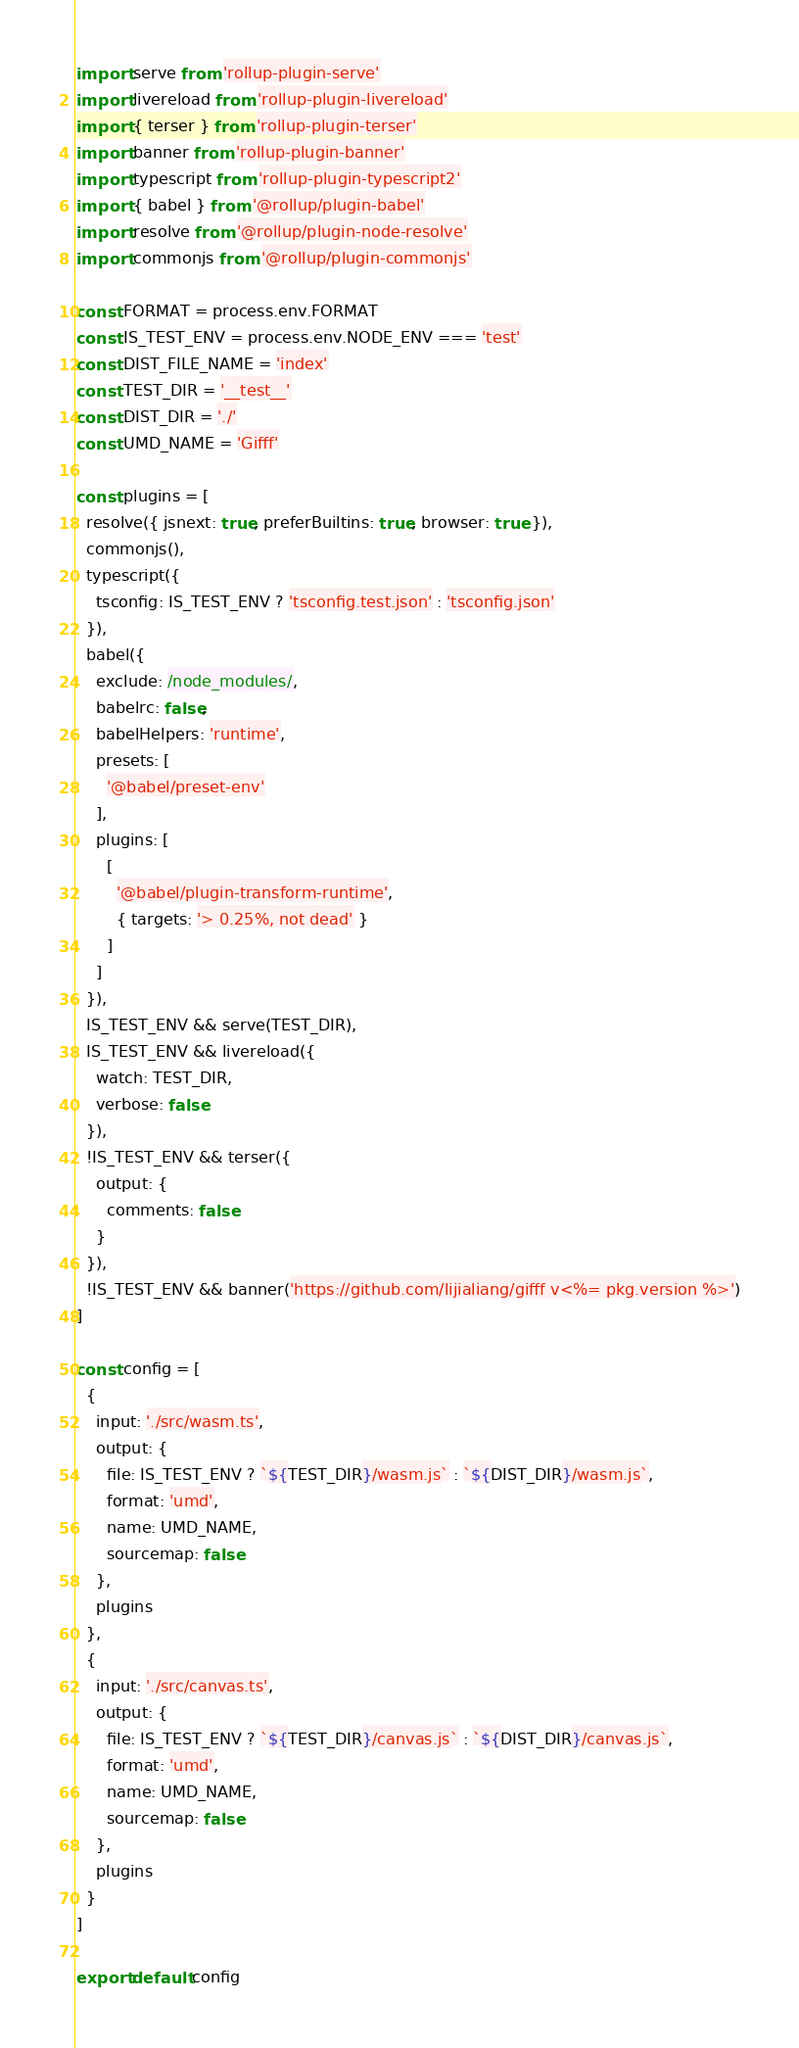<code> <loc_0><loc_0><loc_500><loc_500><_JavaScript_>import serve from 'rollup-plugin-serve'
import livereload from 'rollup-plugin-livereload'
import { terser } from 'rollup-plugin-terser'
import banner from 'rollup-plugin-banner'
import typescript from 'rollup-plugin-typescript2'
import { babel } from '@rollup/plugin-babel'
import resolve from '@rollup/plugin-node-resolve'
import commonjs from '@rollup/plugin-commonjs'

const FORMAT = process.env.FORMAT
const IS_TEST_ENV = process.env.NODE_ENV === 'test'
const DIST_FILE_NAME = 'index'
const TEST_DIR = '__test__'
const DIST_DIR = './'
const UMD_NAME = 'Gifff'

const plugins = [
  resolve({ jsnext: true, preferBuiltins: true, browser: true }),
  commonjs(),
  typescript({
    tsconfig: IS_TEST_ENV ? 'tsconfig.test.json' : 'tsconfig.json'
  }),
  babel({
    exclude: /node_modules/,
    babelrc: false,
    babelHelpers: 'runtime',
    presets: [
      '@babel/preset-env'
    ],
    plugins: [
      [
        '@babel/plugin-transform-runtime',
        { targets: '> 0.25%, not dead' }
      ]
    ]
  }),
  IS_TEST_ENV && serve(TEST_DIR),
  IS_TEST_ENV && livereload({
    watch: TEST_DIR,
    verbose: false
  }),
  !IS_TEST_ENV && terser({
    output: {
      comments: false
    }
  }),
  !IS_TEST_ENV && banner('https://github.com/lijialiang/gifff v<%= pkg.version %>')
]

const config = [
  {
    input: './src/wasm.ts',
    output: {
      file: IS_TEST_ENV ? `${TEST_DIR}/wasm.js` : `${DIST_DIR}/wasm.js`,
      format: 'umd',
      name: UMD_NAME,
      sourcemap: false
    },
    plugins
  },
  {
    input: './src/canvas.ts',
    output: {
      file: IS_TEST_ENV ? `${TEST_DIR}/canvas.js` : `${DIST_DIR}/canvas.js`,
      format: 'umd',
      name: UMD_NAME,
      sourcemap: false
    },
    plugins
  }
]

export default config
</code> 